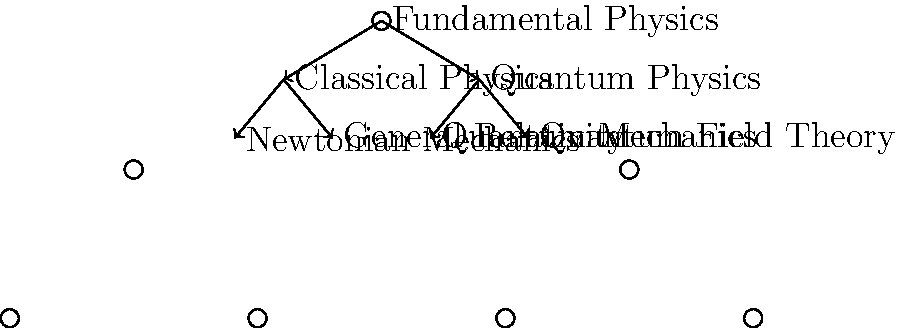In the hierarchical structure of fundamental physical theories represented above, which branch poses the most significant challenge for unification with its counterpart, and why is this unification crucial for addressing the quantum gravity problem? To answer this question, we need to analyze the structure and implications of the diagram:

1. The diagram shows a hierarchical structure of fundamental physical theories.
2. At the top level, we have "Fundamental Physics" which branches into two main categories: "Classical Physics" and "Quantum Physics".
3. Classical Physics further branches into "Newtonian Mechanics" and "General Relativity".
4. Quantum Physics branches into "Quantum Mechanics" and "Quantum Field Theory".

5. The most significant challenge for unification lies between General Relativity and Quantum Field Theory because:
   a) General Relativity describes gravity and the large-scale structure of spacetime.
   b) Quantum Field Theory describes the behavior of particles and forces at the quantum level.
   c) These theories are fundamentally incompatible in their current forms.

6. The unification of these branches is crucial for addressing the quantum gravity problem because:
   a) Quantum gravity seeks to reconcile the principles of quantum mechanics with general relativity.
   b) It aims to provide a unified description of all fundamental forces, including gravity, at all scales.
   c) This unification is necessary to understand phenomena where both quantum effects and strong gravitational fields are important, such as black holes and the early universe.

7. The quantum gravity problem arises from the inconsistency between the continuous, smooth spacetime of general relativity and the discrete, probabilistic nature of quantum mechanics.

8. Resolving this inconsistency would lead to a more fundamental understanding of the nature of space, time, and matter at the most basic level.

Therefore, the unification of General Relativity and Quantum Field Theory is the most crucial challenge in addressing the quantum gravity problem, as it would bridge the gap between our understanding of the macroscopic and microscopic worlds.
Answer: General Relativity and Quantum Field Theory 